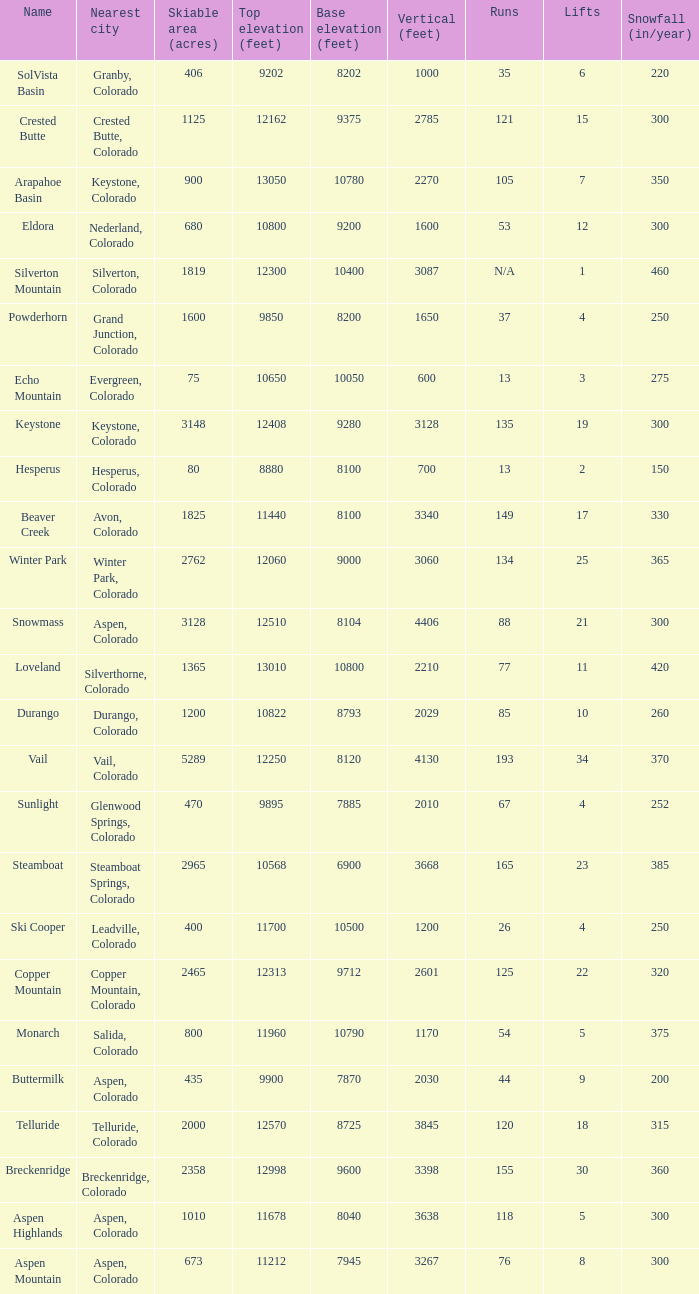If there are 11 lifts, what is the base elevation? 10800.0. 